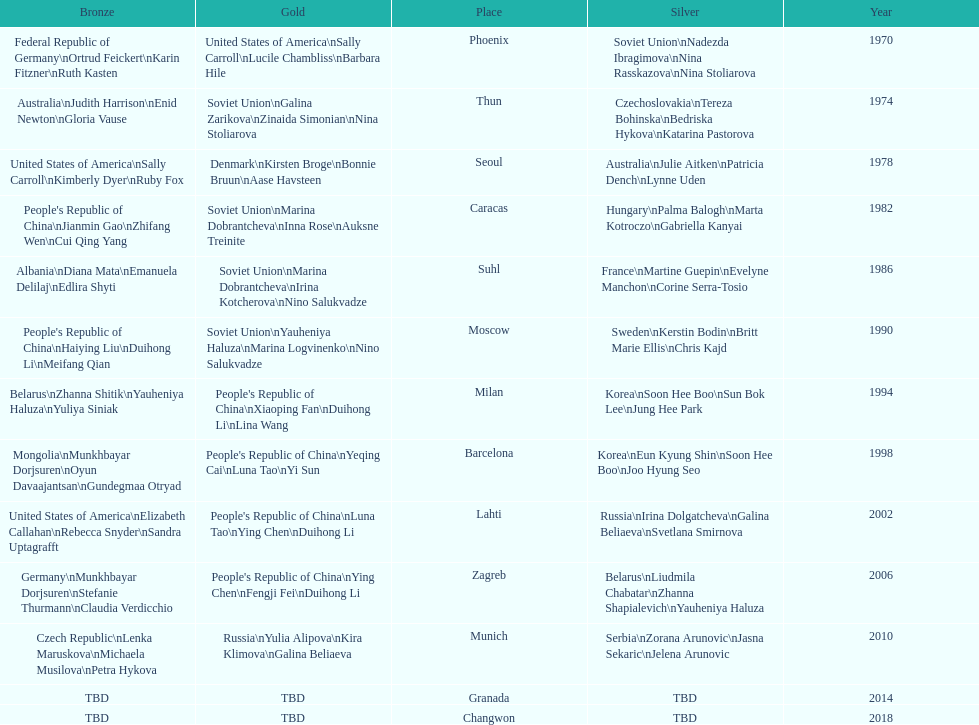How many times has germany won bronze? 2. 